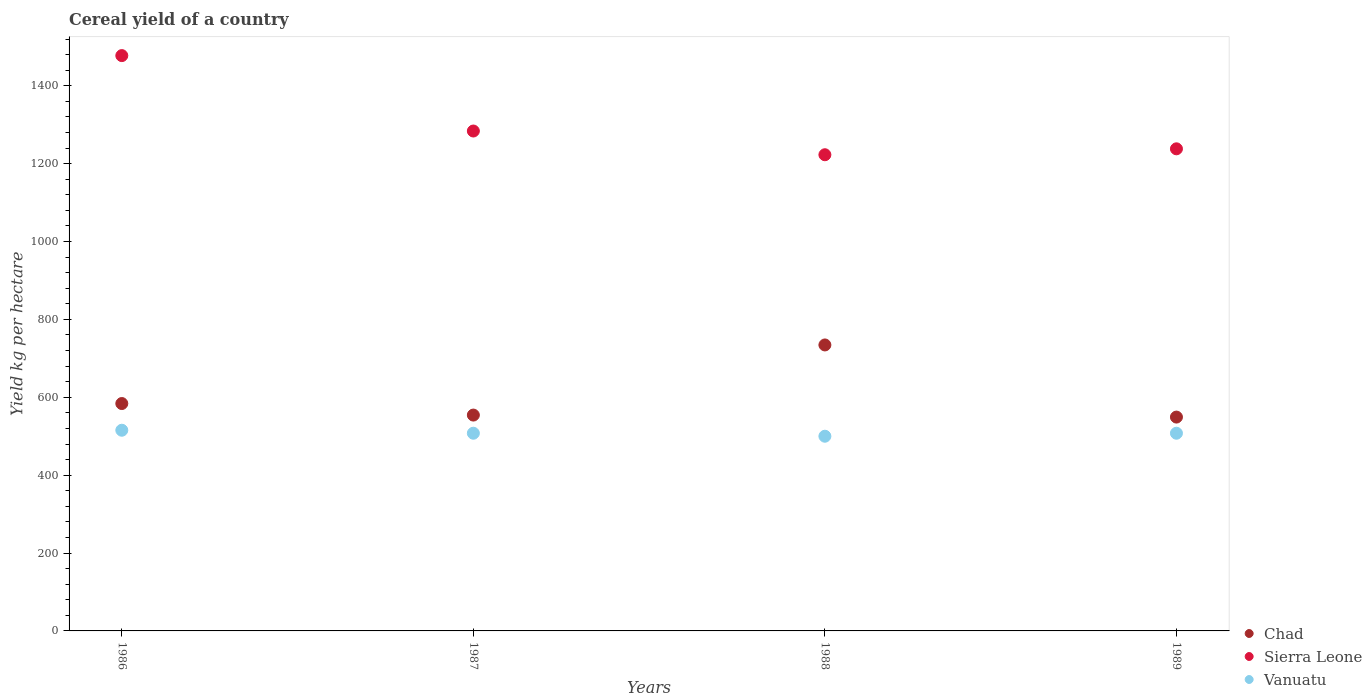How many different coloured dotlines are there?
Your answer should be very brief. 3. Is the number of dotlines equal to the number of legend labels?
Provide a short and direct response. Yes. What is the total cereal yield in Vanuatu in 1987?
Your answer should be compact. 507.69. Across all years, what is the maximum total cereal yield in Sierra Leone?
Provide a short and direct response. 1477.48. Across all years, what is the minimum total cereal yield in Vanuatu?
Offer a terse response. 500. In which year was the total cereal yield in Sierra Leone minimum?
Provide a succinct answer. 1988. What is the total total cereal yield in Sierra Leone in the graph?
Offer a terse response. 5222.27. What is the difference between the total cereal yield in Chad in 1986 and that in 1988?
Offer a terse response. -150.46. What is the difference between the total cereal yield in Vanuatu in 1988 and the total cereal yield in Sierra Leone in 1986?
Offer a terse response. -977.48. What is the average total cereal yield in Vanuatu per year?
Your answer should be very brief. 507.69. In the year 1988, what is the difference between the total cereal yield in Vanuatu and total cereal yield in Sierra Leone?
Keep it short and to the point. -722.89. What is the ratio of the total cereal yield in Chad in 1986 to that in 1989?
Offer a very short reply. 1.06. What is the difference between the highest and the second highest total cereal yield in Chad?
Offer a very short reply. 150.46. What is the difference between the highest and the lowest total cereal yield in Sierra Leone?
Provide a succinct answer. 254.59. In how many years, is the total cereal yield in Vanuatu greater than the average total cereal yield in Vanuatu taken over all years?
Offer a terse response. 1. Does the total cereal yield in Sierra Leone monotonically increase over the years?
Keep it short and to the point. No. How many years are there in the graph?
Keep it short and to the point. 4. What is the difference between two consecutive major ticks on the Y-axis?
Keep it short and to the point. 200. Does the graph contain any zero values?
Provide a succinct answer. No. Does the graph contain grids?
Give a very brief answer. No. Where does the legend appear in the graph?
Provide a succinct answer. Bottom right. What is the title of the graph?
Your response must be concise. Cereal yield of a country. Does "Armenia" appear as one of the legend labels in the graph?
Provide a short and direct response. No. What is the label or title of the Y-axis?
Offer a terse response. Yield kg per hectare. What is the Yield kg per hectare in Chad in 1986?
Your answer should be very brief. 583.96. What is the Yield kg per hectare of Sierra Leone in 1986?
Provide a succinct answer. 1477.48. What is the Yield kg per hectare in Vanuatu in 1986?
Your answer should be compact. 515.38. What is the Yield kg per hectare in Chad in 1987?
Keep it short and to the point. 554.32. What is the Yield kg per hectare of Sierra Leone in 1987?
Provide a short and direct response. 1283.82. What is the Yield kg per hectare of Vanuatu in 1987?
Your answer should be compact. 507.69. What is the Yield kg per hectare of Chad in 1988?
Your response must be concise. 734.41. What is the Yield kg per hectare in Sierra Leone in 1988?
Offer a terse response. 1222.89. What is the Yield kg per hectare of Vanuatu in 1988?
Provide a short and direct response. 500. What is the Yield kg per hectare of Chad in 1989?
Your answer should be compact. 549.17. What is the Yield kg per hectare of Sierra Leone in 1989?
Offer a very short reply. 1238.09. What is the Yield kg per hectare of Vanuatu in 1989?
Your answer should be compact. 507.69. Across all years, what is the maximum Yield kg per hectare in Chad?
Keep it short and to the point. 734.41. Across all years, what is the maximum Yield kg per hectare in Sierra Leone?
Your answer should be very brief. 1477.48. Across all years, what is the maximum Yield kg per hectare of Vanuatu?
Your answer should be very brief. 515.38. Across all years, what is the minimum Yield kg per hectare of Chad?
Your answer should be very brief. 549.17. Across all years, what is the minimum Yield kg per hectare in Sierra Leone?
Your answer should be compact. 1222.89. What is the total Yield kg per hectare of Chad in the graph?
Keep it short and to the point. 2421.86. What is the total Yield kg per hectare in Sierra Leone in the graph?
Offer a very short reply. 5222.27. What is the total Yield kg per hectare of Vanuatu in the graph?
Provide a short and direct response. 2030.77. What is the difference between the Yield kg per hectare in Chad in 1986 and that in 1987?
Your answer should be compact. 29.64. What is the difference between the Yield kg per hectare in Sierra Leone in 1986 and that in 1987?
Ensure brevity in your answer.  193.66. What is the difference between the Yield kg per hectare of Vanuatu in 1986 and that in 1987?
Your response must be concise. 7.69. What is the difference between the Yield kg per hectare of Chad in 1986 and that in 1988?
Make the answer very short. -150.46. What is the difference between the Yield kg per hectare in Sierra Leone in 1986 and that in 1988?
Ensure brevity in your answer.  254.59. What is the difference between the Yield kg per hectare of Vanuatu in 1986 and that in 1988?
Your answer should be very brief. 15.38. What is the difference between the Yield kg per hectare in Chad in 1986 and that in 1989?
Provide a succinct answer. 34.79. What is the difference between the Yield kg per hectare in Sierra Leone in 1986 and that in 1989?
Your answer should be very brief. 239.39. What is the difference between the Yield kg per hectare in Vanuatu in 1986 and that in 1989?
Offer a very short reply. 7.69. What is the difference between the Yield kg per hectare in Chad in 1987 and that in 1988?
Keep it short and to the point. -180.09. What is the difference between the Yield kg per hectare of Sierra Leone in 1987 and that in 1988?
Your response must be concise. 60.92. What is the difference between the Yield kg per hectare in Vanuatu in 1987 and that in 1988?
Your answer should be very brief. 7.69. What is the difference between the Yield kg per hectare in Chad in 1987 and that in 1989?
Provide a succinct answer. 5.15. What is the difference between the Yield kg per hectare of Sierra Leone in 1987 and that in 1989?
Offer a terse response. 45.73. What is the difference between the Yield kg per hectare of Vanuatu in 1987 and that in 1989?
Provide a short and direct response. 0. What is the difference between the Yield kg per hectare in Chad in 1988 and that in 1989?
Keep it short and to the point. 185.24. What is the difference between the Yield kg per hectare in Sierra Leone in 1988 and that in 1989?
Your answer should be compact. -15.19. What is the difference between the Yield kg per hectare in Vanuatu in 1988 and that in 1989?
Ensure brevity in your answer.  -7.69. What is the difference between the Yield kg per hectare of Chad in 1986 and the Yield kg per hectare of Sierra Leone in 1987?
Keep it short and to the point. -699.86. What is the difference between the Yield kg per hectare of Chad in 1986 and the Yield kg per hectare of Vanuatu in 1987?
Give a very brief answer. 76.26. What is the difference between the Yield kg per hectare in Sierra Leone in 1986 and the Yield kg per hectare in Vanuatu in 1987?
Offer a terse response. 969.79. What is the difference between the Yield kg per hectare in Chad in 1986 and the Yield kg per hectare in Sierra Leone in 1988?
Your response must be concise. -638.94. What is the difference between the Yield kg per hectare in Chad in 1986 and the Yield kg per hectare in Vanuatu in 1988?
Your response must be concise. 83.96. What is the difference between the Yield kg per hectare of Sierra Leone in 1986 and the Yield kg per hectare of Vanuatu in 1988?
Your response must be concise. 977.48. What is the difference between the Yield kg per hectare in Chad in 1986 and the Yield kg per hectare in Sierra Leone in 1989?
Your answer should be very brief. -654.13. What is the difference between the Yield kg per hectare in Chad in 1986 and the Yield kg per hectare in Vanuatu in 1989?
Give a very brief answer. 76.26. What is the difference between the Yield kg per hectare in Sierra Leone in 1986 and the Yield kg per hectare in Vanuatu in 1989?
Ensure brevity in your answer.  969.79. What is the difference between the Yield kg per hectare of Chad in 1987 and the Yield kg per hectare of Sierra Leone in 1988?
Make the answer very short. -668.57. What is the difference between the Yield kg per hectare in Chad in 1987 and the Yield kg per hectare in Vanuatu in 1988?
Ensure brevity in your answer.  54.32. What is the difference between the Yield kg per hectare of Sierra Leone in 1987 and the Yield kg per hectare of Vanuatu in 1988?
Your answer should be very brief. 783.82. What is the difference between the Yield kg per hectare of Chad in 1987 and the Yield kg per hectare of Sierra Leone in 1989?
Your answer should be compact. -683.76. What is the difference between the Yield kg per hectare of Chad in 1987 and the Yield kg per hectare of Vanuatu in 1989?
Offer a terse response. 46.63. What is the difference between the Yield kg per hectare of Sierra Leone in 1987 and the Yield kg per hectare of Vanuatu in 1989?
Provide a succinct answer. 776.12. What is the difference between the Yield kg per hectare of Chad in 1988 and the Yield kg per hectare of Sierra Leone in 1989?
Your response must be concise. -503.67. What is the difference between the Yield kg per hectare in Chad in 1988 and the Yield kg per hectare in Vanuatu in 1989?
Give a very brief answer. 226.72. What is the difference between the Yield kg per hectare in Sierra Leone in 1988 and the Yield kg per hectare in Vanuatu in 1989?
Offer a terse response. 715.2. What is the average Yield kg per hectare of Chad per year?
Provide a succinct answer. 605.46. What is the average Yield kg per hectare in Sierra Leone per year?
Keep it short and to the point. 1305.57. What is the average Yield kg per hectare of Vanuatu per year?
Keep it short and to the point. 507.69. In the year 1986, what is the difference between the Yield kg per hectare of Chad and Yield kg per hectare of Sierra Leone?
Keep it short and to the point. -893.52. In the year 1986, what is the difference between the Yield kg per hectare of Chad and Yield kg per hectare of Vanuatu?
Provide a short and direct response. 68.57. In the year 1986, what is the difference between the Yield kg per hectare of Sierra Leone and Yield kg per hectare of Vanuatu?
Your response must be concise. 962.09. In the year 1987, what is the difference between the Yield kg per hectare in Chad and Yield kg per hectare in Sierra Leone?
Make the answer very short. -729.5. In the year 1987, what is the difference between the Yield kg per hectare of Chad and Yield kg per hectare of Vanuatu?
Keep it short and to the point. 46.63. In the year 1987, what is the difference between the Yield kg per hectare in Sierra Leone and Yield kg per hectare in Vanuatu?
Offer a terse response. 776.12. In the year 1988, what is the difference between the Yield kg per hectare in Chad and Yield kg per hectare in Sierra Leone?
Your response must be concise. -488.48. In the year 1988, what is the difference between the Yield kg per hectare of Chad and Yield kg per hectare of Vanuatu?
Offer a terse response. 234.41. In the year 1988, what is the difference between the Yield kg per hectare of Sierra Leone and Yield kg per hectare of Vanuatu?
Make the answer very short. 722.89. In the year 1989, what is the difference between the Yield kg per hectare of Chad and Yield kg per hectare of Sierra Leone?
Offer a terse response. -688.92. In the year 1989, what is the difference between the Yield kg per hectare of Chad and Yield kg per hectare of Vanuatu?
Offer a very short reply. 41.48. In the year 1989, what is the difference between the Yield kg per hectare in Sierra Leone and Yield kg per hectare in Vanuatu?
Give a very brief answer. 730.39. What is the ratio of the Yield kg per hectare of Chad in 1986 to that in 1987?
Ensure brevity in your answer.  1.05. What is the ratio of the Yield kg per hectare of Sierra Leone in 1986 to that in 1987?
Offer a very short reply. 1.15. What is the ratio of the Yield kg per hectare of Vanuatu in 1986 to that in 1987?
Keep it short and to the point. 1.02. What is the ratio of the Yield kg per hectare of Chad in 1986 to that in 1988?
Give a very brief answer. 0.8. What is the ratio of the Yield kg per hectare in Sierra Leone in 1986 to that in 1988?
Give a very brief answer. 1.21. What is the ratio of the Yield kg per hectare in Vanuatu in 1986 to that in 1988?
Provide a short and direct response. 1.03. What is the ratio of the Yield kg per hectare of Chad in 1986 to that in 1989?
Keep it short and to the point. 1.06. What is the ratio of the Yield kg per hectare in Sierra Leone in 1986 to that in 1989?
Your answer should be compact. 1.19. What is the ratio of the Yield kg per hectare of Vanuatu in 1986 to that in 1989?
Offer a terse response. 1.02. What is the ratio of the Yield kg per hectare of Chad in 1987 to that in 1988?
Make the answer very short. 0.75. What is the ratio of the Yield kg per hectare of Sierra Leone in 1987 to that in 1988?
Provide a succinct answer. 1.05. What is the ratio of the Yield kg per hectare of Vanuatu in 1987 to that in 1988?
Provide a succinct answer. 1.02. What is the ratio of the Yield kg per hectare of Chad in 1987 to that in 1989?
Offer a terse response. 1.01. What is the ratio of the Yield kg per hectare in Sierra Leone in 1987 to that in 1989?
Your answer should be very brief. 1.04. What is the ratio of the Yield kg per hectare in Chad in 1988 to that in 1989?
Your response must be concise. 1.34. What is the ratio of the Yield kg per hectare of Sierra Leone in 1988 to that in 1989?
Provide a short and direct response. 0.99. What is the difference between the highest and the second highest Yield kg per hectare of Chad?
Give a very brief answer. 150.46. What is the difference between the highest and the second highest Yield kg per hectare of Sierra Leone?
Give a very brief answer. 193.66. What is the difference between the highest and the second highest Yield kg per hectare in Vanuatu?
Keep it short and to the point. 7.69. What is the difference between the highest and the lowest Yield kg per hectare in Chad?
Offer a very short reply. 185.24. What is the difference between the highest and the lowest Yield kg per hectare of Sierra Leone?
Keep it short and to the point. 254.59. What is the difference between the highest and the lowest Yield kg per hectare in Vanuatu?
Offer a terse response. 15.38. 